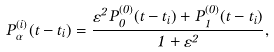<formula> <loc_0><loc_0><loc_500><loc_500>P ^ { ( i ) } _ { \alpha } ( t - t _ { i } ) = \frac { \varepsilon ^ { 2 } P ^ { ( 0 ) } _ { 0 } ( t - t _ { i } ) + P ^ { ( 0 ) } _ { 1 } ( t - t _ { i } ) } { 1 + \varepsilon ^ { 2 } } ,</formula> 